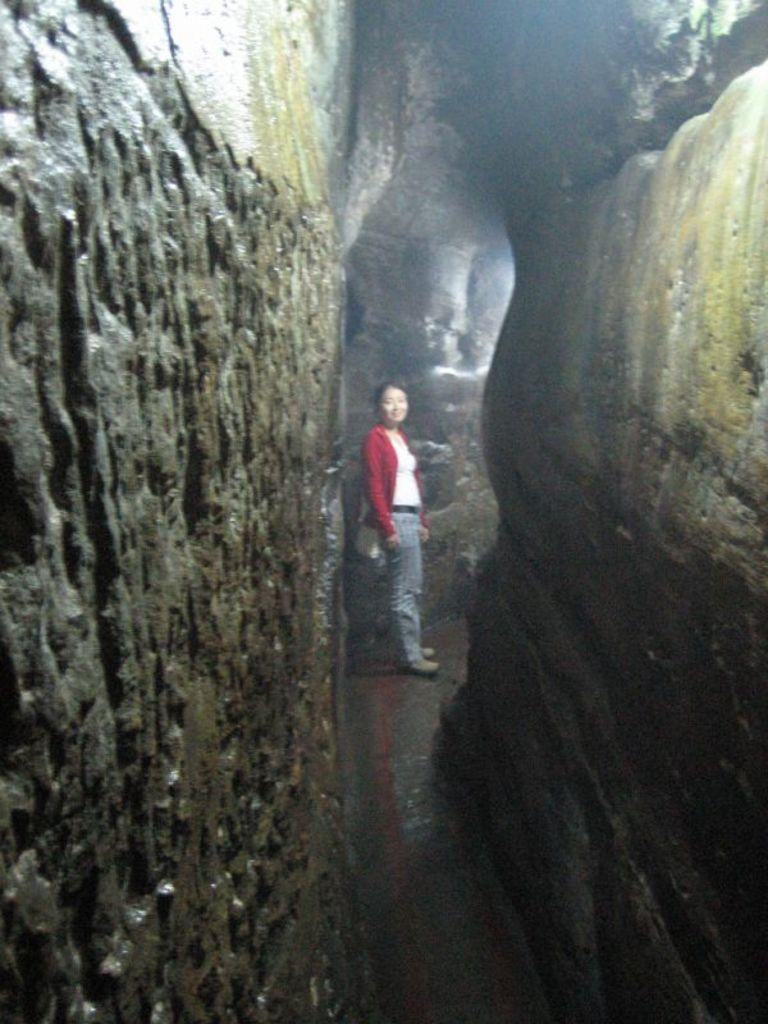What is the main feature of the image? There is a cave in the picture. Can you describe the woman in the image? The woman in the picture is wearing a white top, a red shrug, and blue jeans. How many ducks are visible in the image? There are no ducks present in the image. What type of quilt is covering the woman in the image? The woman in the image is not covered by a quilt; she is wearing a red shrug and a white top. 